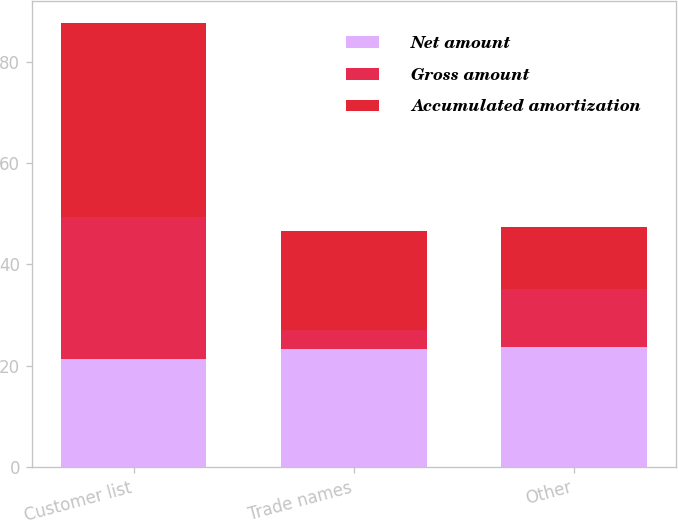<chart> <loc_0><loc_0><loc_500><loc_500><stacked_bar_chart><ecel><fcel>Customer list<fcel>Trade names<fcel>Other<nl><fcel>Net amount<fcel>21.4<fcel>23.3<fcel>23.7<nl><fcel>Gross amount<fcel>27.9<fcel>3.8<fcel>11.5<nl><fcel>Accumulated amortization<fcel>38.3<fcel>19.5<fcel>12.2<nl></chart> 